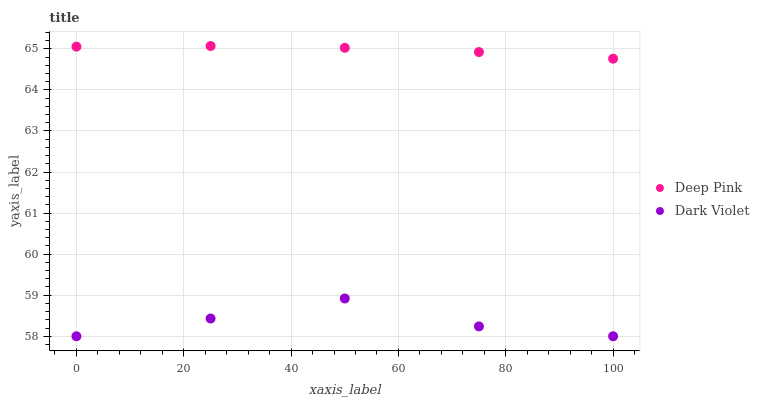Does Dark Violet have the minimum area under the curve?
Answer yes or no. Yes. Does Deep Pink have the maximum area under the curve?
Answer yes or no. Yes. Does Dark Violet have the maximum area under the curve?
Answer yes or no. No. Is Deep Pink the smoothest?
Answer yes or no. Yes. Is Dark Violet the roughest?
Answer yes or no. Yes. Is Dark Violet the smoothest?
Answer yes or no. No. Does Dark Violet have the lowest value?
Answer yes or no. Yes. Does Deep Pink have the highest value?
Answer yes or no. Yes. Does Dark Violet have the highest value?
Answer yes or no. No. Is Dark Violet less than Deep Pink?
Answer yes or no. Yes. Is Deep Pink greater than Dark Violet?
Answer yes or no. Yes. Does Dark Violet intersect Deep Pink?
Answer yes or no. No. 